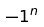Convert formula to latex. <formula><loc_0><loc_0><loc_500><loc_500>- 1 ^ { n }</formula> 